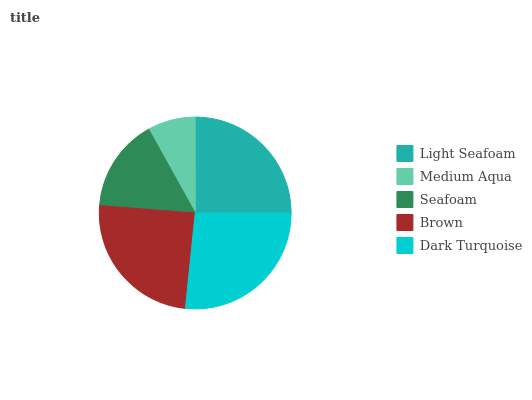Is Medium Aqua the minimum?
Answer yes or no. Yes. Is Dark Turquoise the maximum?
Answer yes or no. Yes. Is Seafoam the minimum?
Answer yes or no. No. Is Seafoam the maximum?
Answer yes or no. No. Is Seafoam greater than Medium Aqua?
Answer yes or no. Yes. Is Medium Aqua less than Seafoam?
Answer yes or no. Yes. Is Medium Aqua greater than Seafoam?
Answer yes or no. No. Is Seafoam less than Medium Aqua?
Answer yes or no. No. Is Brown the high median?
Answer yes or no. Yes. Is Brown the low median?
Answer yes or no. Yes. Is Medium Aqua the high median?
Answer yes or no. No. Is Medium Aqua the low median?
Answer yes or no. No. 